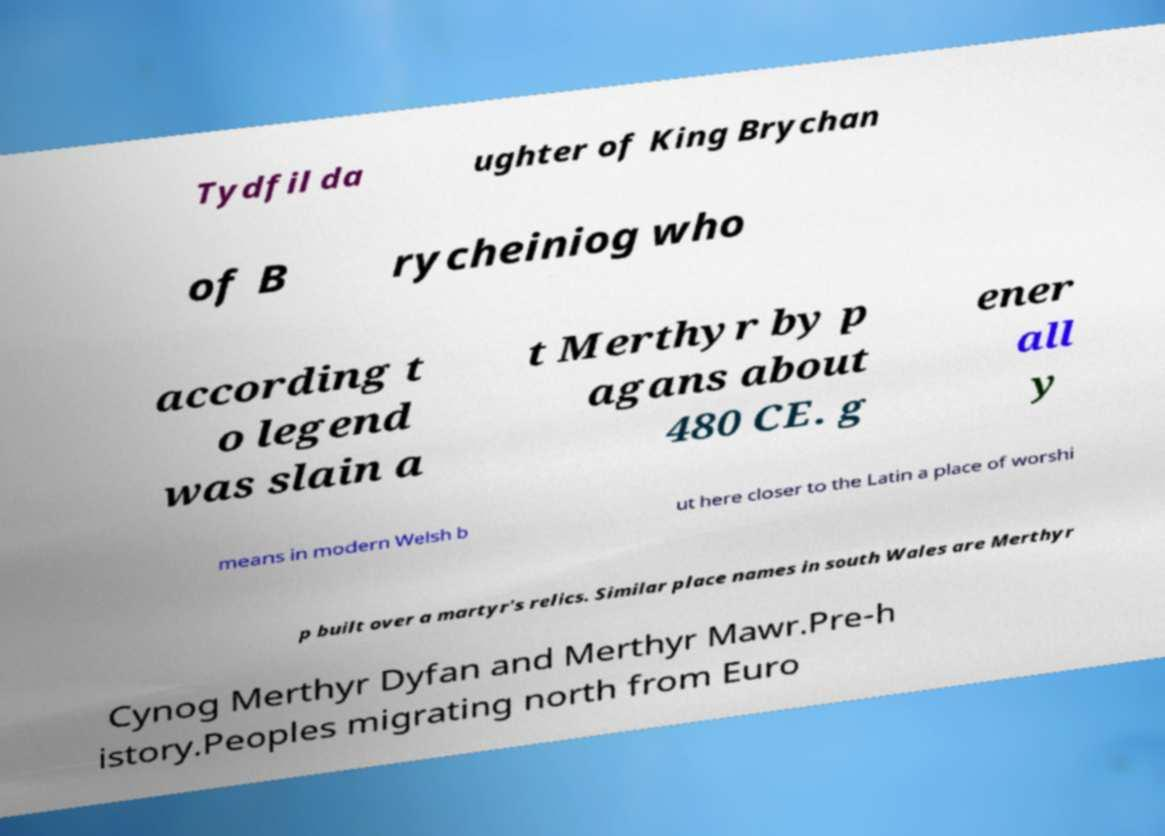Can you accurately transcribe the text from the provided image for me? Tydfil da ughter of King Brychan of B rycheiniog who according t o legend was slain a t Merthyr by p agans about 480 CE. g ener all y means in modern Welsh b ut here closer to the Latin a place of worshi p built over a martyr's relics. Similar place names in south Wales are Merthyr Cynog Merthyr Dyfan and Merthyr Mawr.Pre-h istory.Peoples migrating north from Euro 